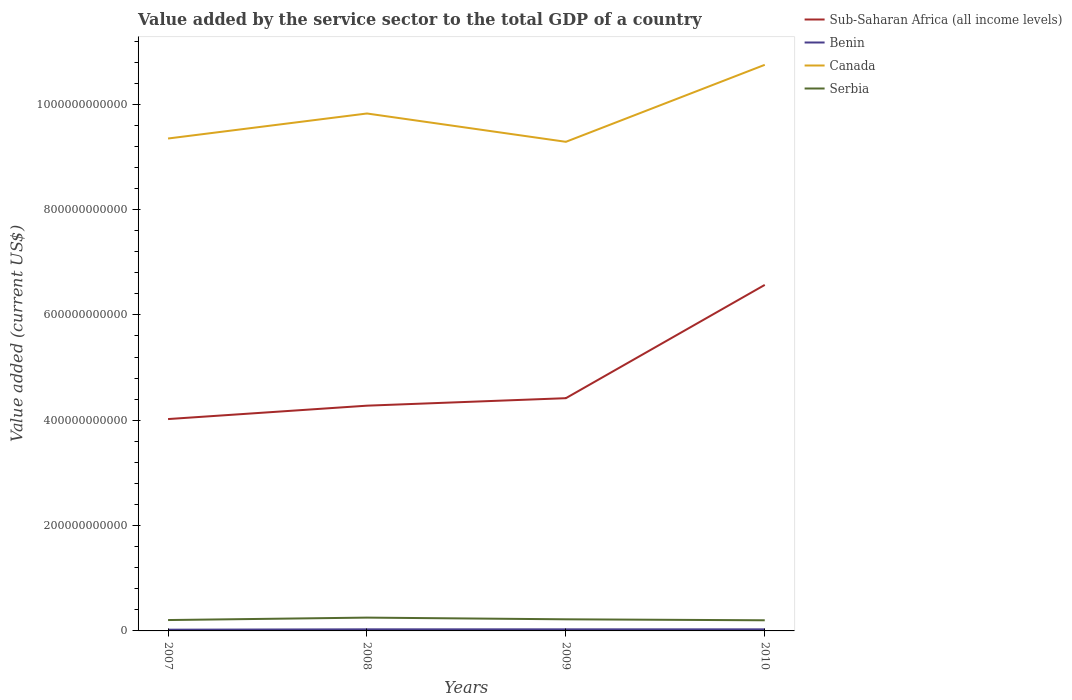How many different coloured lines are there?
Offer a very short reply. 4. Does the line corresponding to Benin intersect with the line corresponding to Serbia?
Ensure brevity in your answer.  No. Across all years, what is the maximum value added by the service sector to the total GDP in Benin?
Ensure brevity in your answer.  2.35e+09. In which year was the value added by the service sector to the total GDP in Serbia maximum?
Provide a succinct answer. 2010. What is the total value added by the service sector to the total GDP in Canada in the graph?
Your answer should be compact. -1.46e+11. What is the difference between the highest and the second highest value added by the service sector to the total GDP in Benin?
Offer a very short reply. 6.68e+08. Is the value added by the service sector to the total GDP in Sub-Saharan Africa (all income levels) strictly greater than the value added by the service sector to the total GDP in Benin over the years?
Offer a very short reply. No. How many lines are there?
Provide a succinct answer. 4. What is the difference between two consecutive major ticks on the Y-axis?
Offer a very short reply. 2.00e+11. Are the values on the major ticks of Y-axis written in scientific E-notation?
Keep it short and to the point. No. How are the legend labels stacked?
Keep it short and to the point. Vertical. What is the title of the graph?
Your answer should be very brief. Value added by the service sector to the total GDP of a country. Does "Greenland" appear as one of the legend labels in the graph?
Provide a short and direct response. No. What is the label or title of the X-axis?
Your answer should be compact. Years. What is the label or title of the Y-axis?
Offer a terse response. Value added (current US$). What is the Value added (current US$) of Sub-Saharan Africa (all income levels) in 2007?
Your answer should be compact. 4.02e+11. What is the Value added (current US$) of Benin in 2007?
Offer a very short reply. 2.35e+09. What is the Value added (current US$) in Canada in 2007?
Your answer should be compact. 9.35e+11. What is the Value added (current US$) in Serbia in 2007?
Give a very brief answer. 2.06e+1. What is the Value added (current US$) in Sub-Saharan Africa (all income levels) in 2008?
Your response must be concise. 4.28e+11. What is the Value added (current US$) of Benin in 2008?
Provide a succinct answer. 3.01e+09. What is the Value added (current US$) of Canada in 2008?
Your answer should be compact. 9.82e+11. What is the Value added (current US$) in Serbia in 2008?
Provide a short and direct response. 2.53e+1. What is the Value added (current US$) of Sub-Saharan Africa (all income levels) in 2009?
Offer a terse response. 4.42e+11. What is the Value added (current US$) in Benin in 2009?
Offer a terse response. 3.02e+09. What is the Value added (current US$) of Canada in 2009?
Keep it short and to the point. 9.29e+11. What is the Value added (current US$) in Serbia in 2009?
Make the answer very short. 2.20e+1. What is the Value added (current US$) in Sub-Saharan Africa (all income levels) in 2010?
Give a very brief answer. 6.57e+11. What is the Value added (current US$) in Benin in 2010?
Your response must be concise. 3.01e+09. What is the Value added (current US$) of Canada in 2010?
Give a very brief answer. 1.07e+12. What is the Value added (current US$) of Serbia in 2010?
Your answer should be very brief. 2.02e+1. Across all years, what is the maximum Value added (current US$) in Sub-Saharan Africa (all income levels)?
Your answer should be compact. 6.57e+11. Across all years, what is the maximum Value added (current US$) in Benin?
Your answer should be compact. 3.02e+09. Across all years, what is the maximum Value added (current US$) in Canada?
Your answer should be compact. 1.07e+12. Across all years, what is the maximum Value added (current US$) of Serbia?
Offer a very short reply. 2.53e+1. Across all years, what is the minimum Value added (current US$) in Sub-Saharan Africa (all income levels)?
Ensure brevity in your answer.  4.02e+11. Across all years, what is the minimum Value added (current US$) of Benin?
Ensure brevity in your answer.  2.35e+09. Across all years, what is the minimum Value added (current US$) in Canada?
Make the answer very short. 9.29e+11. Across all years, what is the minimum Value added (current US$) in Serbia?
Your response must be concise. 2.02e+1. What is the total Value added (current US$) of Sub-Saharan Africa (all income levels) in the graph?
Your answer should be compact. 1.93e+12. What is the total Value added (current US$) of Benin in the graph?
Make the answer very short. 1.14e+1. What is the total Value added (current US$) of Canada in the graph?
Offer a very short reply. 3.92e+12. What is the total Value added (current US$) in Serbia in the graph?
Make the answer very short. 8.81e+1. What is the difference between the Value added (current US$) in Sub-Saharan Africa (all income levels) in 2007 and that in 2008?
Provide a succinct answer. -2.54e+1. What is the difference between the Value added (current US$) in Benin in 2007 and that in 2008?
Your response must be concise. -6.59e+08. What is the difference between the Value added (current US$) in Canada in 2007 and that in 2008?
Offer a very short reply. -4.75e+1. What is the difference between the Value added (current US$) of Serbia in 2007 and that in 2008?
Your response must be concise. -4.63e+09. What is the difference between the Value added (current US$) of Sub-Saharan Africa (all income levels) in 2007 and that in 2009?
Make the answer very short. -3.96e+1. What is the difference between the Value added (current US$) in Benin in 2007 and that in 2009?
Your response must be concise. -6.68e+08. What is the difference between the Value added (current US$) in Canada in 2007 and that in 2009?
Your answer should be compact. 6.28e+09. What is the difference between the Value added (current US$) of Serbia in 2007 and that in 2009?
Provide a short and direct response. -1.40e+09. What is the difference between the Value added (current US$) of Sub-Saharan Africa (all income levels) in 2007 and that in 2010?
Your response must be concise. -2.55e+11. What is the difference between the Value added (current US$) in Benin in 2007 and that in 2010?
Offer a terse response. -6.56e+08. What is the difference between the Value added (current US$) of Canada in 2007 and that in 2010?
Your response must be concise. -1.40e+11. What is the difference between the Value added (current US$) of Serbia in 2007 and that in 2010?
Offer a terse response. 4.47e+08. What is the difference between the Value added (current US$) of Sub-Saharan Africa (all income levels) in 2008 and that in 2009?
Make the answer very short. -1.42e+1. What is the difference between the Value added (current US$) of Benin in 2008 and that in 2009?
Give a very brief answer. -8.70e+06. What is the difference between the Value added (current US$) in Canada in 2008 and that in 2009?
Ensure brevity in your answer.  5.38e+1. What is the difference between the Value added (current US$) of Serbia in 2008 and that in 2009?
Provide a succinct answer. 3.23e+09. What is the difference between the Value added (current US$) of Sub-Saharan Africa (all income levels) in 2008 and that in 2010?
Your answer should be compact. -2.29e+11. What is the difference between the Value added (current US$) in Benin in 2008 and that in 2010?
Make the answer very short. 3.03e+06. What is the difference between the Value added (current US$) in Canada in 2008 and that in 2010?
Offer a terse response. -9.24e+1. What is the difference between the Value added (current US$) of Serbia in 2008 and that in 2010?
Give a very brief answer. 5.08e+09. What is the difference between the Value added (current US$) of Sub-Saharan Africa (all income levels) in 2009 and that in 2010?
Your response must be concise. -2.15e+11. What is the difference between the Value added (current US$) in Benin in 2009 and that in 2010?
Provide a succinct answer. 1.17e+07. What is the difference between the Value added (current US$) in Canada in 2009 and that in 2010?
Offer a terse response. -1.46e+11. What is the difference between the Value added (current US$) in Serbia in 2009 and that in 2010?
Your answer should be compact. 1.85e+09. What is the difference between the Value added (current US$) in Sub-Saharan Africa (all income levels) in 2007 and the Value added (current US$) in Benin in 2008?
Provide a short and direct response. 3.99e+11. What is the difference between the Value added (current US$) of Sub-Saharan Africa (all income levels) in 2007 and the Value added (current US$) of Canada in 2008?
Provide a short and direct response. -5.80e+11. What is the difference between the Value added (current US$) in Sub-Saharan Africa (all income levels) in 2007 and the Value added (current US$) in Serbia in 2008?
Offer a terse response. 3.77e+11. What is the difference between the Value added (current US$) in Benin in 2007 and the Value added (current US$) in Canada in 2008?
Make the answer very short. -9.80e+11. What is the difference between the Value added (current US$) of Benin in 2007 and the Value added (current US$) of Serbia in 2008?
Your answer should be very brief. -2.29e+1. What is the difference between the Value added (current US$) of Canada in 2007 and the Value added (current US$) of Serbia in 2008?
Keep it short and to the point. 9.10e+11. What is the difference between the Value added (current US$) in Sub-Saharan Africa (all income levels) in 2007 and the Value added (current US$) in Benin in 2009?
Your response must be concise. 3.99e+11. What is the difference between the Value added (current US$) in Sub-Saharan Africa (all income levels) in 2007 and the Value added (current US$) in Canada in 2009?
Provide a short and direct response. -5.26e+11. What is the difference between the Value added (current US$) in Sub-Saharan Africa (all income levels) in 2007 and the Value added (current US$) in Serbia in 2009?
Your response must be concise. 3.80e+11. What is the difference between the Value added (current US$) of Benin in 2007 and the Value added (current US$) of Canada in 2009?
Offer a terse response. -9.26e+11. What is the difference between the Value added (current US$) in Benin in 2007 and the Value added (current US$) in Serbia in 2009?
Ensure brevity in your answer.  -1.97e+1. What is the difference between the Value added (current US$) of Canada in 2007 and the Value added (current US$) of Serbia in 2009?
Give a very brief answer. 9.13e+11. What is the difference between the Value added (current US$) in Sub-Saharan Africa (all income levels) in 2007 and the Value added (current US$) in Benin in 2010?
Keep it short and to the point. 3.99e+11. What is the difference between the Value added (current US$) in Sub-Saharan Africa (all income levels) in 2007 and the Value added (current US$) in Canada in 2010?
Keep it short and to the point. -6.73e+11. What is the difference between the Value added (current US$) in Sub-Saharan Africa (all income levels) in 2007 and the Value added (current US$) in Serbia in 2010?
Offer a very short reply. 3.82e+11. What is the difference between the Value added (current US$) of Benin in 2007 and the Value added (current US$) of Canada in 2010?
Your response must be concise. -1.07e+12. What is the difference between the Value added (current US$) of Benin in 2007 and the Value added (current US$) of Serbia in 2010?
Your response must be concise. -1.78e+1. What is the difference between the Value added (current US$) of Canada in 2007 and the Value added (current US$) of Serbia in 2010?
Give a very brief answer. 9.15e+11. What is the difference between the Value added (current US$) of Sub-Saharan Africa (all income levels) in 2008 and the Value added (current US$) of Benin in 2009?
Provide a succinct answer. 4.25e+11. What is the difference between the Value added (current US$) of Sub-Saharan Africa (all income levels) in 2008 and the Value added (current US$) of Canada in 2009?
Give a very brief answer. -5.01e+11. What is the difference between the Value added (current US$) in Sub-Saharan Africa (all income levels) in 2008 and the Value added (current US$) in Serbia in 2009?
Offer a very short reply. 4.06e+11. What is the difference between the Value added (current US$) in Benin in 2008 and the Value added (current US$) in Canada in 2009?
Your answer should be very brief. -9.26e+11. What is the difference between the Value added (current US$) of Benin in 2008 and the Value added (current US$) of Serbia in 2009?
Offer a terse response. -1.90e+1. What is the difference between the Value added (current US$) of Canada in 2008 and the Value added (current US$) of Serbia in 2009?
Your answer should be compact. 9.60e+11. What is the difference between the Value added (current US$) of Sub-Saharan Africa (all income levels) in 2008 and the Value added (current US$) of Benin in 2010?
Your answer should be compact. 4.25e+11. What is the difference between the Value added (current US$) in Sub-Saharan Africa (all income levels) in 2008 and the Value added (current US$) in Canada in 2010?
Keep it short and to the point. -6.47e+11. What is the difference between the Value added (current US$) in Sub-Saharan Africa (all income levels) in 2008 and the Value added (current US$) in Serbia in 2010?
Your answer should be very brief. 4.07e+11. What is the difference between the Value added (current US$) in Benin in 2008 and the Value added (current US$) in Canada in 2010?
Provide a succinct answer. -1.07e+12. What is the difference between the Value added (current US$) of Benin in 2008 and the Value added (current US$) of Serbia in 2010?
Keep it short and to the point. -1.72e+1. What is the difference between the Value added (current US$) in Canada in 2008 and the Value added (current US$) in Serbia in 2010?
Offer a very short reply. 9.62e+11. What is the difference between the Value added (current US$) of Sub-Saharan Africa (all income levels) in 2009 and the Value added (current US$) of Benin in 2010?
Your answer should be very brief. 4.39e+11. What is the difference between the Value added (current US$) in Sub-Saharan Africa (all income levels) in 2009 and the Value added (current US$) in Canada in 2010?
Your answer should be very brief. -6.33e+11. What is the difference between the Value added (current US$) in Sub-Saharan Africa (all income levels) in 2009 and the Value added (current US$) in Serbia in 2010?
Your response must be concise. 4.22e+11. What is the difference between the Value added (current US$) of Benin in 2009 and the Value added (current US$) of Canada in 2010?
Your response must be concise. -1.07e+12. What is the difference between the Value added (current US$) in Benin in 2009 and the Value added (current US$) in Serbia in 2010?
Give a very brief answer. -1.72e+1. What is the difference between the Value added (current US$) in Canada in 2009 and the Value added (current US$) in Serbia in 2010?
Give a very brief answer. 9.08e+11. What is the average Value added (current US$) of Sub-Saharan Africa (all income levels) per year?
Ensure brevity in your answer.  4.82e+11. What is the average Value added (current US$) of Benin per year?
Provide a short and direct response. 2.85e+09. What is the average Value added (current US$) of Canada per year?
Your response must be concise. 9.80e+11. What is the average Value added (current US$) in Serbia per year?
Ensure brevity in your answer.  2.20e+1. In the year 2007, what is the difference between the Value added (current US$) in Sub-Saharan Africa (all income levels) and Value added (current US$) in Benin?
Your answer should be compact. 4.00e+11. In the year 2007, what is the difference between the Value added (current US$) in Sub-Saharan Africa (all income levels) and Value added (current US$) in Canada?
Your answer should be compact. -5.33e+11. In the year 2007, what is the difference between the Value added (current US$) of Sub-Saharan Africa (all income levels) and Value added (current US$) of Serbia?
Give a very brief answer. 3.82e+11. In the year 2007, what is the difference between the Value added (current US$) of Benin and Value added (current US$) of Canada?
Your response must be concise. -9.33e+11. In the year 2007, what is the difference between the Value added (current US$) in Benin and Value added (current US$) in Serbia?
Your answer should be very brief. -1.83e+1. In the year 2007, what is the difference between the Value added (current US$) of Canada and Value added (current US$) of Serbia?
Ensure brevity in your answer.  9.14e+11. In the year 2008, what is the difference between the Value added (current US$) in Sub-Saharan Africa (all income levels) and Value added (current US$) in Benin?
Keep it short and to the point. 4.25e+11. In the year 2008, what is the difference between the Value added (current US$) in Sub-Saharan Africa (all income levels) and Value added (current US$) in Canada?
Your answer should be very brief. -5.55e+11. In the year 2008, what is the difference between the Value added (current US$) in Sub-Saharan Africa (all income levels) and Value added (current US$) in Serbia?
Make the answer very short. 4.02e+11. In the year 2008, what is the difference between the Value added (current US$) in Benin and Value added (current US$) in Canada?
Your answer should be very brief. -9.79e+11. In the year 2008, what is the difference between the Value added (current US$) in Benin and Value added (current US$) in Serbia?
Offer a terse response. -2.23e+1. In the year 2008, what is the difference between the Value added (current US$) of Canada and Value added (current US$) of Serbia?
Provide a succinct answer. 9.57e+11. In the year 2009, what is the difference between the Value added (current US$) of Sub-Saharan Africa (all income levels) and Value added (current US$) of Benin?
Offer a terse response. 4.39e+11. In the year 2009, what is the difference between the Value added (current US$) of Sub-Saharan Africa (all income levels) and Value added (current US$) of Canada?
Provide a succinct answer. -4.87e+11. In the year 2009, what is the difference between the Value added (current US$) of Sub-Saharan Africa (all income levels) and Value added (current US$) of Serbia?
Provide a succinct answer. 4.20e+11. In the year 2009, what is the difference between the Value added (current US$) of Benin and Value added (current US$) of Canada?
Provide a succinct answer. -9.26e+11. In the year 2009, what is the difference between the Value added (current US$) of Benin and Value added (current US$) of Serbia?
Offer a terse response. -1.90e+1. In the year 2009, what is the difference between the Value added (current US$) in Canada and Value added (current US$) in Serbia?
Offer a terse response. 9.07e+11. In the year 2010, what is the difference between the Value added (current US$) in Sub-Saharan Africa (all income levels) and Value added (current US$) in Benin?
Make the answer very short. 6.54e+11. In the year 2010, what is the difference between the Value added (current US$) in Sub-Saharan Africa (all income levels) and Value added (current US$) in Canada?
Provide a short and direct response. -4.18e+11. In the year 2010, what is the difference between the Value added (current US$) of Sub-Saharan Africa (all income levels) and Value added (current US$) of Serbia?
Give a very brief answer. 6.37e+11. In the year 2010, what is the difference between the Value added (current US$) in Benin and Value added (current US$) in Canada?
Provide a succinct answer. -1.07e+12. In the year 2010, what is the difference between the Value added (current US$) in Benin and Value added (current US$) in Serbia?
Your response must be concise. -1.72e+1. In the year 2010, what is the difference between the Value added (current US$) in Canada and Value added (current US$) in Serbia?
Keep it short and to the point. 1.05e+12. What is the ratio of the Value added (current US$) of Sub-Saharan Africa (all income levels) in 2007 to that in 2008?
Make the answer very short. 0.94. What is the ratio of the Value added (current US$) of Benin in 2007 to that in 2008?
Offer a terse response. 0.78. What is the ratio of the Value added (current US$) in Canada in 2007 to that in 2008?
Keep it short and to the point. 0.95. What is the ratio of the Value added (current US$) in Serbia in 2007 to that in 2008?
Provide a succinct answer. 0.82. What is the ratio of the Value added (current US$) of Sub-Saharan Africa (all income levels) in 2007 to that in 2009?
Your answer should be very brief. 0.91. What is the ratio of the Value added (current US$) of Benin in 2007 to that in 2009?
Offer a terse response. 0.78. What is the ratio of the Value added (current US$) of Canada in 2007 to that in 2009?
Provide a short and direct response. 1.01. What is the ratio of the Value added (current US$) of Serbia in 2007 to that in 2009?
Provide a succinct answer. 0.94. What is the ratio of the Value added (current US$) in Sub-Saharan Africa (all income levels) in 2007 to that in 2010?
Provide a short and direct response. 0.61. What is the ratio of the Value added (current US$) of Benin in 2007 to that in 2010?
Give a very brief answer. 0.78. What is the ratio of the Value added (current US$) in Canada in 2007 to that in 2010?
Ensure brevity in your answer.  0.87. What is the ratio of the Value added (current US$) in Serbia in 2007 to that in 2010?
Offer a terse response. 1.02. What is the ratio of the Value added (current US$) of Sub-Saharan Africa (all income levels) in 2008 to that in 2009?
Offer a terse response. 0.97. What is the ratio of the Value added (current US$) of Canada in 2008 to that in 2009?
Provide a succinct answer. 1.06. What is the ratio of the Value added (current US$) in Serbia in 2008 to that in 2009?
Offer a terse response. 1.15. What is the ratio of the Value added (current US$) in Sub-Saharan Africa (all income levels) in 2008 to that in 2010?
Your answer should be compact. 0.65. What is the ratio of the Value added (current US$) in Benin in 2008 to that in 2010?
Provide a succinct answer. 1. What is the ratio of the Value added (current US$) in Canada in 2008 to that in 2010?
Offer a very short reply. 0.91. What is the ratio of the Value added (current US$) of Serbia in 2008 to that in 2010?
Provide a succinct answer. 1.25. What is the ratio of the Value added (current US$) of Sub-Saharan Africa (all income levels) in 2009 to that in 2010?
Provide a short and direct response. 0.67. What is the ratio of the Value added (current US$) of Benin in 2009 to that in 2010?
Your answer should be very brief. 1. What is the ratio of the Value added (current US$) in Canada in 2009 to that in 2010?
Keep it short and to the point. 0.86. What is the ratio of the Value added (current US$) of Serbia in 2009 to that in 2010?
Make the answer very short. 1.09. What is the difference between the highest and the second highest Value added (current US$) in Sub-Saharan Africa (all income levels)?
Make the answer very short. 2.15e+11. What is the difference between the highest and the second highest Value added (current US$) in Benin?
Offer a very short reply. 8.70e+06. What is the difference between the highest and the second highest Value added (current US$) of Canada?
Offer a very short reply. 9.24e+1. What is the difference between the highest and the second highest Value added (current US$) in Serbia?
Keep it short and to the point. 3.23e+09. What is the difference between the highest and the lowest Value added (current US$) in Sub-Saharan Africa (all income levels)?
Make the answer very short. 2.55e+11. What is the difference between the highest and the lowest Value added (current US$) in Benin?
Offer a terse response. 6.68e+08. What is the difference between the highest and the lowest Value added (current US$) in Canada?
Your response must be concise. 1.46e+11. What is the difference between the highest and the lowest Value added (current US$) in Serbia?
Offer a very short reply. 5.08e+09. 